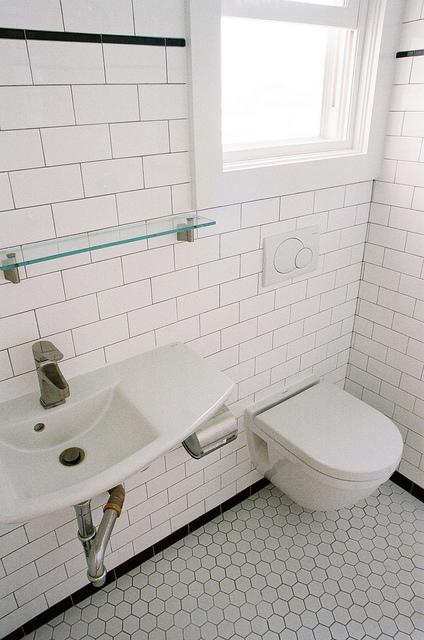Is the drain pipe on the sink exposed?
Keep it brief. Yes. What kind of walls and flooring is here?
Answer briefly. Tile. What is above the toilet?
Short answer required. Window. 